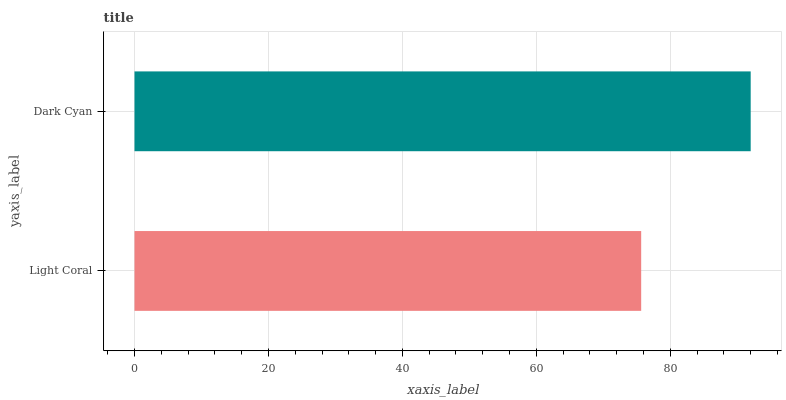Is Light Coral the minimum?
Answer yes or no. Yes. Is Dark Cyan the maximum?
Answer yes or no. Yes. Is Dark Cyan the minimum?
Answer yes or no. No. Is Dark Cyan greater than Light Coral?
Answer yes or no. Yes. Is Light Coral less than Dark Cyan?
Answer yes or no. Yes. Is Light Coral greater than Dark Cyan?
Answer yes or no. No. Is Dark Cyan less than Light Coral?
Answer yes or no. No. Is Dark Cyan the high median?
Answer yes or no. Yes. Is Light Coral the low median?
Answer yes or no. Yes. Is Light Coral the high median?
Answer yes or no. No. Is Dark Cyan the low median?
Answer yes or no. No. 